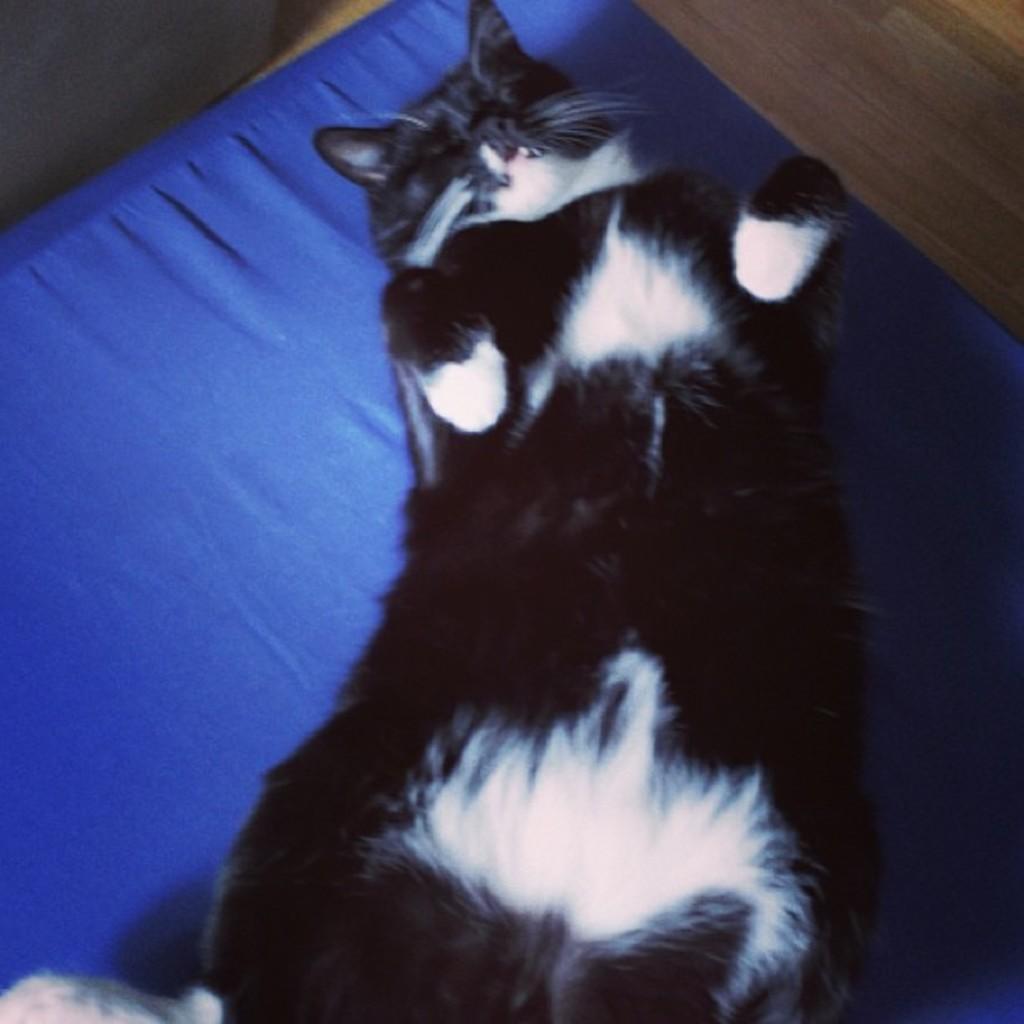In one or two sentences, can you explain what this image depicts? In this image there is a cat laying on the mat. At the bottom of the image there is a floor. 